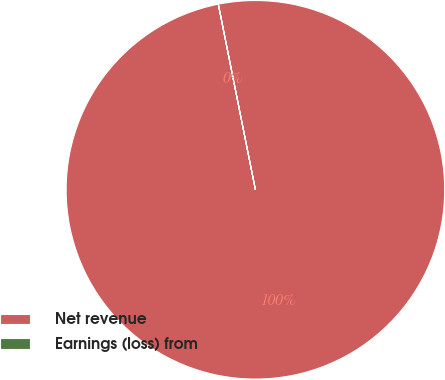Convert chart to OTSL. <chart><loc_0><loc_0><loc_500><loc_500><pie_chart><fcel>Net revenue<fcel>Earnings (loss) from<nl><fcel>99.99%<fcel>0.01%<nl></chart> 